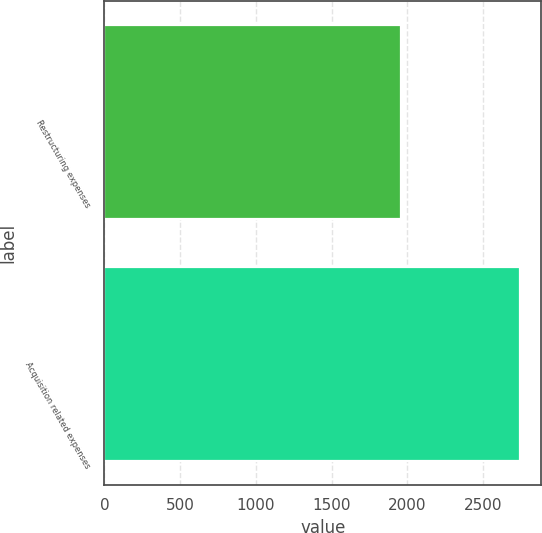Convert chart to OTSL. <chart><loc_0><loc_0><loc_500><loc_500><bar_chart><fcel>Restructuring expenses<fcel>Acquisition related expenses<nl><fcel>1960<fcel>2745<nl></chart> 